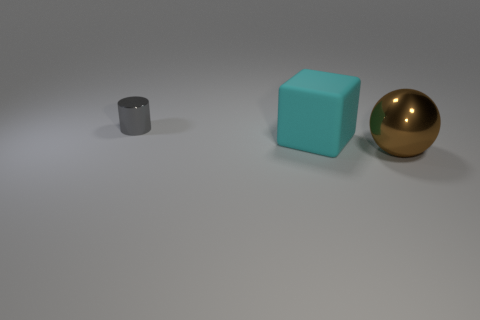Add 3 tiny gray things. How many objects exist? 6 Subtract all spheres. How many objects are left? 2 Subtract 0 cyan spheres. How many objects are left? 3 Subtract all small metal cylinders. Subtract all green cubes. How many objects are left? 2 Add 2 small gray cylinders. How many small gray cylinders are left? 3 Add 3 big rubber things. How many big rubber things exist? 4 